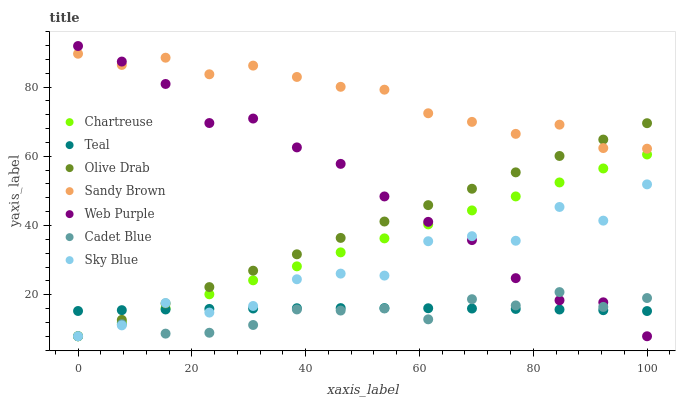Does Cadet Blue have the minimum area under the curve?
Answer yes or no. Yes. Does Sandy Brown have the maximum area under the curve?
Answer yes or no. Yes. Does Chartreuse have the minimum area under the curve?
Answer yes or no. No. Does Chartreuse have the maximum area under the curve?
Answer yes or no. No. Is Chartreuse the smoothest?
Answer yes or no. Yes. Is Sky Blue the roughest?
Answer yes or no. Yes. Is Web Purple the smoothest?
Answer yes or no. No. Is Web Purple the roughest?
Answer yes or no. No. Does Cadet Blue have the lowest value?
Answer yes or no. Yes. Does Teal have the lowest value?
Answer yes or no. No. Does Web Purple have the highest value?
Answer yes or no. Yes. Does Chartreuse have the highest value?
Answer yes or no. No. Is Cadet Blue less than Sandy Brown?
Answer yes or no. Yes. Is Sandy Brown greater than Chartreuse?
Answer yes or no. Yes. Does Teal intersect Cadet Blue?
Answer yes or no. Yes. Is Teal less than Cadet Blue?
Answer yes or no. No. Is Teal greater than Cadet Blue?
Answer yes or no. No. Does Cadet Blue intersect Sandy Brown?
Answer yes or no. No. 